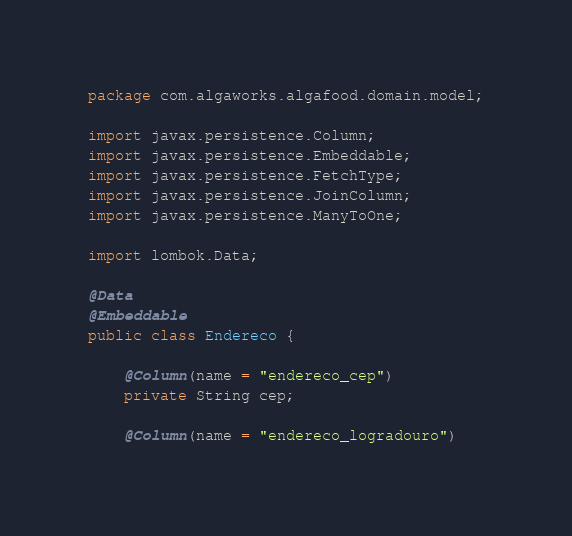<code> <loc_0><loc_0><loc_500><loc_500><_Java_>package com.algaworks.algafood.domain.model;

import javax.persistence.Column;
import javax.persistence.Embeddable;
import javax.persistence.FetchType;
import javax.persistence.JoinColumn;
import javax.persistence.ManyToOne;

import lombok.Data;

@Data
@Embeddable
public class Endereco {

	@Column(name = "endereco_cep")
	private String cep;
	
	@Column(name = "endereco_logradouro")</code> 